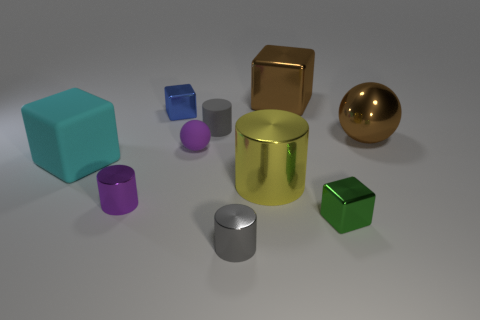Subtract all brown shiny blocks. How many blocks are left? 3 Subtract all brown spheres. How many spheres are left? 1 Subtract all cubes. How many objects are left? 6 Subtract all blue balls. How many gray cylinders are left? 2 Subtract 2 cubes. How many cubes are left? 2 Subtract 0 yellow spheres. How many objects are left? 10 Subtract all purple spheres. Subtract all green cubes. How many spheres are left? 1 Subtract all small purple rubber spheres. Subtract all small purple matte things. How many objects are left? 8 Add 9 small blue objects. How many small blue objects are left? 10 Add 6 large spheres. How many large spheres exist? 7 